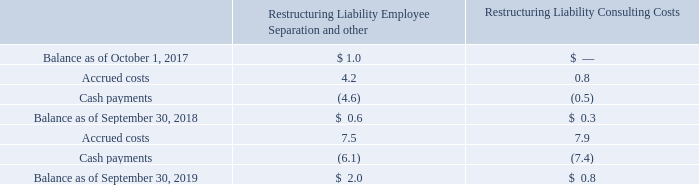The following table presents a rollforward of our restructuring liability as of September 30, 2019, which is included within accrued compensation and other current liabilities within our Consolidated Balance Sheet, (in millions):
Certain restructuring costs are based upon estimates. Actual amounts paid may ultimately differ from these estimates. If additional costs are incurred or recognized amounts exceed costs, such changes in estimates will be recognized when incurred.
Where is the restructuring liability included within? Accrued compensation and other current liabilities within our consolidated balance sheet, (in millions). What is the  Balance as of October 1, 2017 for Restructuring Liability Employee Separation and other?
Answer scale should be: million. $ 1.0. Which elements of restructuring liability are considered in the table? Employee separation and other, consulting costs. What is the change in balance as of September 30, 2019 from September 30, 2018 for Restructuring Liability Consulting Costs?
Answer scale should be: million. 0.8-0.3
Answer: 0.5. What is the change in balance as of September 30, 2019 from September 30, 2018 for Restructuring Liability Employee Separation and other?
Answer scale should be: million. 2.0-0.6
Answer: 1.4. What is the percentage change in balance as of September 30, 2019 from September 30, 2018 for Restructuring Liability Consulting Costs?
Answer scale should be: percent. (0.8-0.3)/0.3
Answer: 166.67. 